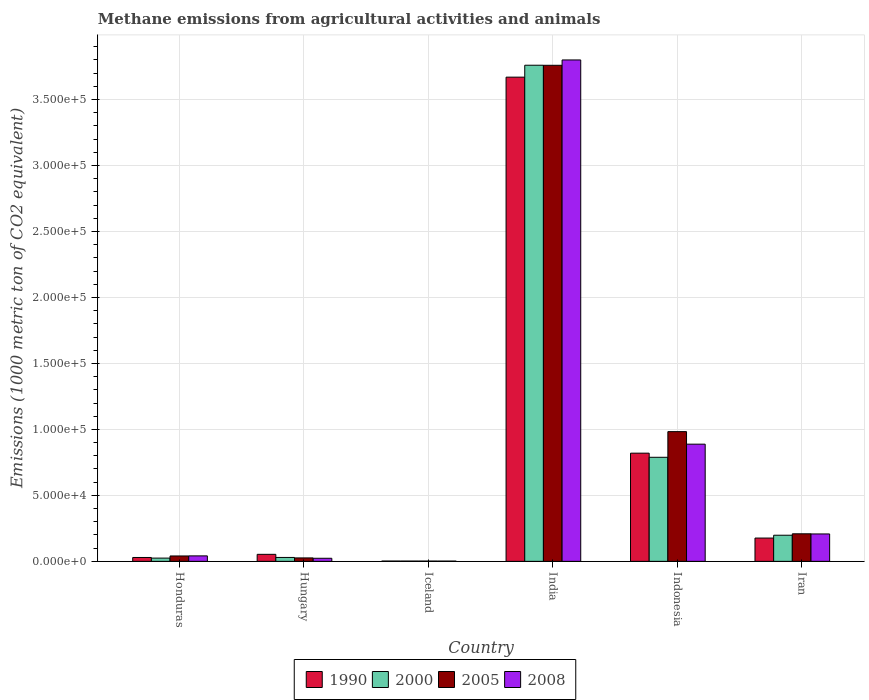How many groups of bars are there?
Make the answer very short. 6. Are the number of bars per tick equal to the number of legend labels?
Your answer should be very brief. Yes. How many bars are there on the 2nd tick from the left?
Offer a terse response. 4. How many bars are there on the 2nd tick from the right?
Keep it short and to the point. 4. What is the label of the 6th group of bars from the left?
Your answer should be compact. Iran. What is the amount of methane emitted in 1990 in Iceland?
Give a very brief answer. 245.3. Across all countries, what is the maximum amount of methane emitted in 2005?
Your answer should be compact. 3.76e+05. Across all countries, what is the minimum amount of methane emitted in 1990?
Provide a short and direct response. 245.3. In which country was the amount of methane emitted in 2008 maximum?
Offer a terse response. India. What is the total amount of methane emitted in 2008 in the graph?
Your answer should be very brief. 4.96e+05. What is the difference between the amount of methane emitted in 2008 in Hungary and that in Indonesia?
Offer a terse response. -8.65e+04. What is the difference between the amount of methane emitted in 2000 in India and the amount of methane emitted in 1990 in Iceland?
Ensure brevity in your answer.  3.76e+05. What is the average amount of methane emitted in 2008 per country?
Keep it short and to the point. 8.27e+04. What is the difference between the amount of methane emitted of/in 1990 and amount of methane emitted of/in 2008 in Hungary?
Your response must be concise. 2992.4. In how many countries, is the amount of methane emitted in 1990 greater than 40000 1000 metric ton?
Ensure brevity in your answer.  2. What is the ratio of the amount of methane emitted in 1990 in Honduras to that in Hungary?
Your answer should be very brief. 0.55. Is the difference between the amount of methane emitted in 1990 in Hungary and India greater than the difference between the amount of methane emitted in 2008 in Hungary and India?
Provide a succinct answer. Yes. What is the difference between the highest and the second highest amount of methane emitted in 1990?
Provide a succinct answer. 2.85e+05. What is the difference between the highest and the lowest amount of methane emitted in 1990?
Your response must be concise. 3.67e+05. Is it the case that in every country, the sum of the amount of methane emitted in 2008 and amount of methane emitted in 1990 is greater than the sum of amount of methane emitted in 2005 and amount of methane emitted in 2000?
Your response must be concise. No. What does the 3rd bar from the left in Indonesia represents?
Your answer should be very brief. 2005. What does the 2nd bar from the right in Indonesia represents?
Offer a terse response. 2005. Is it the case that in every country, the sum of the amount of methane emitted in 2008 and amount of methane emitted in 2005 is greater than the amount of methane emitted in 2000?
Ensure brevity in your answer.  Yes. How many bars are there?
Make the answer very short. 24. Are all the bars in the graph horizontal?
Give a very brief answer. No. How many countries are there in the graph?
Your response must be concise. 6. What is the difference between two consecutive major ticks on the Y-axis?
Ensure brevity in your answer.  5.00e+04. Are the values on the major ticks of Y-axis written in scientific E-notation?
Your answer should be very brief. Yes. Does the graph contain any zero values?
Offer a very short reply. No. Where does the legend appear in the graph?
Provide a succinct answer. Bottom center. How are the legend labels stacked?
Your response must be concise. Horizontal. What is the title of the graph?
Your response must be concise. Methane emissions from agricultural activities and animals. What is the label or title of the Y-axis?
Your response must be concise. Emissions (1000 metric ton of CO2 equivalent). What is the Emissions (1000 metric ton of CO2 equivalent) in 1990 in Honduras?
Keep it short and to the point. 2946.5. What is the Emissions (1000 metric ton of CO2 equivalent) in 2000 in Honduras?
Make the answer very short. 2470.9. What is the Emissions (1000 metric ton of CO2 equivalent) in 2005 in Honduras?
Give a very brief answer. 4084.8. What is the Emissions (1000 metric ton of CO2 equivalent) of 2008 in Honduras?
Your response must be concise. 4149.3. What is the Emissions (1000 metric ton of CO2 equivalent) of 1990 in Hungary?
Provide a short and direct response. 5327.6. What is the Emissions (1000 metric ton of CO2 equivalent) in 2000 in Hungary?
Your response must be concise. 2961.9. What is the Emissions (1000 metric ton of CO2 equivalent) in 2005 in Hungary?
Give a very brief answer. 2613. What is the Emissions (1000 metric ton of CO2 equivalent) of 2008 in Hungary?
Offer a terse response. 2335.2. What is the Emissions (1000 metric ton of CO2 equivalent) in 1990 in Iceland?
Provide a short and direct response. 245.3. What is the Emissions (1000 metric ton of CO2 equivalent) in 2000 in Iceland?
Your response must be concise. 223.7. What is the Emissions (1000 metric ton of CO2 equivalent) in 2005 in Iceland?
Keep it short and to the point. 214.9. What is the Emissions (1000 metric ton of CO2 equivalent) in 2008 in Iceland?
Your response must be concise. 209.2. What is the Emissions (1000 metric ton of CO2 equivalent) in 1990 in India?
Your response must be concise. 3.67e+05. What is the Emissions (1000 metric ton of CO2 equivalent) of 2000 in India?
Provide a succinct answer. 3.76e+05. What is the Emissions (1000 metric ton of CO2 equivalent) in 2005 in India?
Offer a terse response. 3.76e+05. What is the Emissions (1000 metric ton of CO2 equivalent) of 2008 in India?
Provide a short and direct response. 3.80e+05. What is the Emissions (1000 metric ton of CO2 equivalent) in 1990 in Indonesia?
Make the answer very short. 8.20e+04. What is the Emissions (1000 metric ton of CO2 equivalent) in 2000 in Indonesia?
Your answer should be very brief. 7.89e+04. What is the Emissions (1000 metric ton of CO2 equivalent) in 2005 in Indonesia?
Make the answer very short. 9.83e+04. What is the Emissions (1000 metric ton of CO2 equivalent) in 2008 in Indonesia?
Offer a terse response. 8.88e+04. What is the Emissions (1000 metric ton of CO2 equivalent) in 1990 in Iran?
Make the answer very short. 1.77e+04. What is the Emissions (1000 metric ton of CO2 equivalent) of 2000 in Iran?
Offer a very short reply. 1.98e+04. What is the Emissions (1000 metric ton of CO2 equivalent) in 2005 in Iran?
Your answer should be very brief. 2.09e+04. What is the Emissions (1000 metric ton of CO2 equivalent) of 2008 in Iran?
Make the answer very short. 2.08e+04. Across all countries, what is the maximum Emissions (1000 metric ton of CO2 equivalent) in 1990?
Offer a very short reply. 3.67e+05. Across all countries, what is the maximum Emissions (1000 metric ton of CO2 equivalent) of 2000?
Your answer should be very brief. 3.76e+05. Across all countries, what is the maximum Emissions (1000 metric ton of CO2 equivalent) of 2005?
Keep it short and to the point. 3.76e+05. Across all countries, what is the maximum Emissions (1000 metric ton of CO2 equivalent) of 2008?
Your answer should be compact. 3.80e+05. Across all countries, what is the minimum Emissions (1000 metric ton of CO2 equivalent) in 1990?
Ensure brevity in your answer.  245.3. Across all countries, what is the minimum Emissions (1000 metric ton of CO2 equivalent) of 2000?
Offer a very short reply. 223.7. Across all countries, what is the minimum Emissions (1000 metric ton of CO2 equivalent) of 2005?
Offer a very short reply. 214.9. Across all countries, what is the minimum Emissions (1000 metric ton of CO2 equivalent) in 2008?
Your response must be concise. 209.2. What is the total Emissions (1000 metric ton of CO2 equivalent) in 1990 in the graph?
Your response must be concise. 4.75e+05. What is the total Emissions (1000 metric ton of CO2 equivalent) of 2000 in the graph?
Ensure brevity in your answer.  4.80e+05. What is the total Emissions (1000 metric ton of CO2 equivalent) in 2005 in the graph?
Your response must be concise. 5.02e+05. What is the total Emissions (1000 metric ton of CO2 equivalent) of 2008 in the graph?
Give a very brief answer. 4.96e+05. What is the difference between the Emissions (1000 metric ton of CO2 equivalent) of 1990 in Honduras and that in Hungary?
Ensure brevity in your answer.  -2381.1. What is the difference between the Emissions (1000 metric ton of CO2 equivalent) in 2000 in Honduras and that in Hungary?
Ensure brevity in your answer.  -491. What is the difference between the Emissions (1000 metric ton of CO2 equivalent) of 2005 in Honduras and that in Hungary?
Your response must be concise. 1471.8. What is the difference between the Emissions (1000 metric ton of CO2 equivalent) of 2008 in Honduras and that in Hungary?
Your answer should be compact. 1814.1. What is the difference between the Emissions (1000 metric ton of CO2 equivalent) of 1990 in Honduras and that in Iceland?
Make the answer very short. 2701.2. What is the difference between the Emissions (1000 metric ton of CO2 equivalent) in 2000 in Honduras and that in Iceland?
Make the answer very short. 2247.2. What is the difference between the Emissions (1000 metric ton of CO2 equivalent) in 2005 in Honduras and that in Iceland?
Your answer should be very brief. 3869.9. What is the difference between the Emissions (1000 metric ton of CO2 equivalent) in 2008 in Honduras and that in Iceland?
Give a very brief answer. 3940.1. What is the difference between the Emissions (1000 metric ton of CO2 equivalent) of 1990 in Honduras and that in India?
Provide a succinct answer. -3.64e+05. What is the difference between the Emissions (1000 metric ton of CO2 equivalent) of 2000 in Honduras and that in India?
Ensure brevity in your answer.  -3.74e+05. What is the difference between the Emissions (1000 metric ton of CO2 equivalent) in 2005 in Honduras and that in India?
Your response must be concise. -3.72e+05. What is the difference between the Emissions (1000 metric ton of CO2 equivalent) of 2008 in Honduras and that in India?
Provide a succinct answer. -3.76e+05. What is the difference between the Emissions (1000 metric ton of CO2 equivalent) in 1990 in Honduras and that in Indonesia?
Keep it short and to the point. -7.91e+04. What is the difference between the Emissions (1000 metric ton of CO2 equivalent) of 2000 in Honduras and that in Indonesia?
Make the answer very short. -7.64e+04. What is the difference between the Emissions (1000 metric ton of CO2 equivalent) of 2005 in Honduras and that in Indonesia?
Keep it short and to the point. -9.42e+04. What is the difference between the Emissions (1000 metric ton of CO2 equivalent) of 2008 in Honduras and that in Indonesia?
Provide a short and direct response. -8.47e+04. What is the difference between the Emissions (1000 metric ton of CO2 equivalent) of 1990 in Honduras and that in Iran?
Your answer should be compact. -1.47e+04. What is the difference between the Emissions (1000 metric ton of CO2 equivalent) in 2000 in Honduras and that in Iran?
Provide a succinct answer. -1.73e+04. What is the difference between the Emissions (1000 metric ton of CO2 equivalent) in 2005 in Honduras and that in Iran?
Your answer should be compact. -1.68e+04. What is the difference between the Emissions (1000 metric ton of CO2 equivalent) in 2008 in Honduras and that in Iran?
Provide a short and direct response. -1.66e+04. What is the difference between the Emissions (1000 metric ton of CO2 equivalent) of 1990 in Hungary and that in Iceland?
Your answer should be compact. 5082.3. What is the difference between the Emissions (1000 metric ton of CO2 equivalent) in 2000 in Hungary and that in Iceland?
Provide a short and direct response. 2738.2. What is the difference between the Emissions (1000 metric ton of CO2 equivalent) of 2005 in Hungary and that in Iceland?
Provide a short and direct response. 2398.1. What is the difference between the Emissions (1000 metric ton of CO2 equivalent) of 2008 in Hungary and that in Iceland?
Make the answer very short. 2126. What is the difference between the Emissions (1000 metric ton of CO2 equivalent) of 1990 in Hungary and that in India?
Offer a very short reply. -3.62e+05. What is the difference between the Emissions (1000 metric ton of CO2 equivalent) in 2000 in Hungary and that in India?
Keep it short and to the point. -3.73e+05. What is the difference between the Emissions (1000 metric ton of CO2 equivalent) in 2005 in Hungary and that in India?
Your response must be concise. -3.73e+05. What is the difference between the Emissions (1000 metric ton of CO2 equivalent) of 2008 in Hungary and that in India?
Make the answer very short. -3.78e+05. What is the difference between the Emissions (1000 metric ton of CO2 equivalent) in 1990 in Hungary and that in Indonesia?
Make the answer very short. -7.67e+04. What is the difference between the Emissions (1000 metric ton of CO2 equivalent) of 2000 in Hungary and that in Indonesia?
Give a very brief answer. -7.59e+04. What is the difference between the Emissions (1000 metric ton of CO2 equivalent) in 2005 in Hungary and that in Indonesia?
Your answer should be very brief. -9.57e+04. What is the difference between the Emissions (1000 metric ton of CO2 equivalent) in 2008 in Hungary and that in Indonesia?
Provide a short and direct response. -8.65e+04. What is the difference between the Emissions (1000 metric ton of CO2 equivalent) of 1990 in Hungary and that in Iran?
Your response must be concise. -1.23e+04. What is the difference between the Emissions (1000 metric ton of CO2 equivalent) in 2000 in Hungary and that in Iran?
Your response must be concise. -1.68e+04. What is the difference between the Emissions (1000 metric ton of CO2 equivalent) of 2005 in Hungary and that in Iran?
Keep it short and to the point. -1.83e+04. What is the difference between the Emissions (1000 metric ton of CO2 equivalent) of 2008 in Hungary and that in Iran?
Provide a short and direct response. -1.84e+04. What is the difference between the Emissions (1000 metric ton of CO2 equivalent) of 1990 in Iceland and that in India?
Your response must be concise. -3.67e+05. What is the difference between the Emissions (1000 metric ton of CO2 equivalent) in 2000 in Iceland and that in India?
Your answer should be compact. -3.76e+05. What is the difference between the Emissions (1000 metric ton of CO2 equivalent) of 2005 in Iceland and that in India?
Provide a succinct answer. -3.76e+05. What is the difference between the Emissions (1000 metric ton of CO2 equivalent) of 2008 in Iceland and that in India?
Make the answer very short. -3.80e+05. What is the difference between the Emissions (1000 metric ton of CO2 equivalent) of 1990 in Iceland and that in Indonesia?
Offer a very short reply. -8.18e+04. What is the difference between the Emissions (1000 metric ton of CO2 equivalent) in 2000 in Iceland and that in Indonesia?
Keep it short and to the point. -7.86e+04. What is the difference between the Emissions (1000 metric ton of CO2 equivalent) in 2005 in Iceland and that in Indonesia?
Offer a very short reply. -9.81e+04. What is the difference between the Emissions (1000 metric ton of CO2 equivalent) in 2008 in Iceland and that in Indonesia?
Make the answer very short. -8.86e+04. What is the difference between the Emissions (1000 metric ton of CO2 equivalent) in 1990 in Iceland and that in Iran?
Your answer should be very brief. -1.74e+04. What is the difference between the Emissions (1000 metric ton of CO2 equivalent) of 2000 in Iceland and that in Iran?
Your answer should be very brief. -1.96e+04. What is the difference between the Emissions (1000 metric ton of CO2 equivalent) of 2005 in Iceland and that in Iran?
Give a very brief answer. -2.07e+04. What is the difference between the Emissions (1000 metric ton of CO2 equivalent) in 2008 in Iceland and that in Iran?
Keep it short and to the point. -2.06e+04. What is the difference between the Emissions (1000 metric ton of CO2 equivalent) in 1990 in India and that in Indonesia?
Your response must be concise. 2.85e+05. What is the difference between the Emissions (1000 metric ton of CO2 equivalent) in 2000 in India and that in Indonesia?
Your answer should be very brief. 2.97e+05. What is the difference between the Emissions (1000 metric ton of CO2 equivalent) of 2005 in India and that in Indonesia?
Give a very brief answer. 2.78e+05. What is the difference between the Emissions (1000 metric ton of CO2 equivalent) of 2008 in India and that in Indonesia?
Your response must be concise. 2.91e+05. What is the difference between the Emissions (1000 metric ton of CO2 equivalent) in 1990 in India and that in Iran?
Your answer should be compact. 3.49e+05. What is the difference between the Emissions (1000 metric ton of CO2 equivalent) in 2000 in India and that in Iran?
Your answer should be very brief. 3.56e+05. What is the difference between the Emissions (1000 metric ton of CO2 equivalent) of 2005 in India and that in Iran?
Make the answer very short. 3.55e+05. What is the difference between the Emissions (1000 metric ton of CO2 equivalent) of 2008 in India and that in Iran?
Give a very brief answer. 3.59e+05. What is the difference between the Emissions (1000 metric ton of CO2 equivalent) of 1990 in Indonesia and that in Iran?
Keep it short and to the point. 6.43e+04. What is the difference between the Emissions (1000 metric ton of CO2 equivalent) of 2000 in Indonesia and that in Iran?
Offer a terse response. 5.91e+04. What is the difference between the Emissions (1000 metric ton of CO2 equivalent) of 2005 in Indonesia and that in Iran?
Offer a very short reply. 7.74e+04. What is the difference between the Emissions (1000 metric ton of CO2 equivalent) of 2008 in Indonesia and that in Iran?
Ensure brevity in your answer.  6.80e+04. What is the difference between the Emissions (1000 metric ton of CO2 equivalent) in 1990 in Honduras and the Emissions (1000 metric ton of CO2 equivalent) in 2000 in Hungary?
Ensure brevity in your answer.  -15.4. What is the difference between the Emissions (1000 metric ton of CO2 equivalent) of 1990 in Honduras and the Emissions (1000 metric ton of CO2 equivalent) of 2005 in Hungary?
Your response must be concise. 333.5. What is the difference between the Emissions (1000 metric ton of CO2 equivalent) in 1990 in Honduras and the Emissions (1000 metric ton of CO2 equivalent) in 2008 in Hungary?
Your answer should be compact. 611.3. What is the difference between the Emissions (1000 metric ton of CO2 equivalent) in 2000 in Honduras and the Emissions (1000 metric ton of CO2 equivalent) in 2005 in Hungary?
Offer a very short reply. -142.1. What is the difference between the Emissions (1000 metric ton of CO2 equivalent) of 2000 in Honduras and the Emissions (1000 metric ton of CO2 equivalent) of 2008 in Hungary?
Provide a succinct answer. 135.7. What is the difference between the Emissions (1000 metric ton of CO2 equivalent) in 2005 in Honduras and the Emissions (1000 metric ton of CO2 equivalent) in 2008 in Hungary?
Provide a short and direct response. 1749.6. What is the difference between the Emissions (1000 metric ton of CO2 equivalent) in 1990 in Honduras and the Emissions (1000 metric ton of CO2 equivalent) in 2000 in Iceland?
Your answer should be compact. 2722.8. What is the difference between the Emissions (1000 metric ton of CO2 equivalent) in 1990 in Honduras and the Emissions (1000 metric ton of CO2 equivalent) in 2005 in Iceland?
Your answer should be very brief. 2731.6. What is the difference between the Emissions (1000 metric ton of CO2 equivalent) in 1990 in Honduras and the Emissions (1000 metric ton of CO2 equivalent) in 2008 in Iceland?
Make the answer very short. 2737.3. What is the difference between the Emissions (1000 metric ton of CO2 equivalent) of 2000 in Honduras and the Emissions (1000 metric ton of CO2 equivalent) of 2005 in Iceland?
Ensure brevity in your answer.  2256. What is the difference between the Emissions (1000 metric ton of CO2 equivalent) in 2000 in Honduras and the Emissions (1000 metric ton of CO2 equivalent) in 2008 in Iceland?
Keep it short and to the point. 2261.7. What is the difference between the Emissions (1000 metric ton of CO2 equivalent) of 2005 in Honduras and the Emissions (1000 metric ton of CO2 equivalent) of 2008 in Iceland?
Offer a very short reply. 3875.6. What is the difference between the Emissions (1000 metric ton of CO2 equivalent) in 1990 in Honduras and the Emissions (1000 metric ton of CO2 equivalent) in 2000 in India?
Offer a terse response. -3.73e+05. What is the difference between the Emissions (1000 metric ton of CO2 equivalent) in 1990 in Honduras and the Emissions (1000 metric ton of CO2 equivalent) in 2005 in India?
Provide a succinct answer. -3.73e+05. What is the difference between the Emissions (1000 metric ton of CO2 equivalent) in 1990 in Honduras and the Emissions (1000 metric ton of CO2 equivalent) in 2008 in India?
Make the answer very short. -3.77e+05. What is the difference between the Emissions (1000 metric ton of CO2 equivalent) in 2000 in Honduras and the Emissions (1000 metric ton of CO2 equivalent) in 2005 in India?
Give a very brief answer. -3.73e+05. What is the difference between the Emissions (1000 metric ton of CO2 equivalent) of 2000 in Honduras and the Emissions (1000 metric ton of CO2 equivalent) of 2008 in India?
Provide a succinct answer. -3.78e+05. What is the difference between the Emissions (1000 metric ton of CO2 equivalent) in 2005 in Honduras and the Emissions (1000 metric ton of CO2 equivalent) in 2008 in India?
Offer a very short reply. -3.76e+05. What is the difference between the Emissions (1000 metric ton of CO2 equivalent) in 1990 in Honduras and the Emissions (1000 metric ton of CO2 equivalent) in 2000 in Indonesia?
Offer a very short reply. -7.59e+04. What is the difference between the Emissions (1000 metric ton of CO2 equivalent) of 1990 in Honduras and the Emissions (1000 metric ton of CO2 equivalent) of 2005 in Indonesia?
Your answer should be very brief. -9.54e+04. What is the difference between the Emissions (1000 metric ton of CO2 equivalent) of 1990 in Honduras and the Emissions (1000 metric ton of CO2 equivalent) of 2008 in Indonesia?
Your answer should be very brief. -8.59e+04. What is the difference between the Emissions (1000 metric ton of CO2 equivalent) of 2000 in Honduras and the Emissions (1000 metric ton of CO2 equivalent) of 2005 in Indonesia?
Make the answer very short. -9.58e+04. What is the difference between the Emissions (1000 metric ton of CO2 equivalent) in 2000 in Honduras and the Emissions (1000 metric ton of CO2 equivalent) in 2008 in Indonesia?
Provide a succinct answer. -8.63e+04. What is the difference between the Emissions (1000 metric ton of CO2 equivalent) in 2005 in Honduras and the Emissions (1000 metric ton of CO2 equivalent) in 2008 in Indonesia?
Make the answer very short. -8.47e+04. What is the difference between the Emissions (1000 metric ton of CO2 equivalent) in 1990 in Honduras and the Emissions (1000 metric ton of CO2 equivalent) in 2000 in Iran?
Keep it short and to the point. -1.69e+04. What is the difference between the Emissions (1000 metric ton of CO2 equivalent) in 1990 in Honduras and the Emissions (1000 metric ton of CO2 equivalent) in 2005 in Iran?
Your response must be concise. -1.79e+04. What is the difference between the Emissions (1000 metric ton of CO2 equivalent) in 1990 in Honduras and the Emissions (1000 metric ton of CO2 equivalent) in 2008 in Iran?
Keep it short and to the point. -1.78e+04. What is the difference between the Emissions (1000 metric ton of CO2 equivalent) in 2000 in Honduras and the Emissions (1000 metric ton of CO2 equivalent) in 2005 in Iran?
Your response must be concise. -1.84e+04. What is the difference between the Emissions (1000 metric ton of CO2 equivalent) in 2000 in Honduras and the Emissions (1000 metric ton of CO2 equivalent) in 2008 in Iran?
Provide a succinct answer. -1.83e+04. What is the difference between the Emissions (1000 metric ton of CO2 equivalent) of 2005 in Honduras and the Emissions (1000 metric ton of CO2 equivalent) of 2008 in Iran?
Your answer should be compact. -1.67e+04. What is the difference between the Emissions (1000 metric ton of CO2 equivalent) in 1990 in Hungary and the Emissions (1000 metric ton of CO2 equivalent) in 2000 in Iceland?
Your answer should be very brief. 5103.9. What is the difference between the Emissions (1000 metric ton of CO2 equivalent) in 1990 in Hungary and the Emissions (1000 metric ton of CO2 equivalent) in 2005 in Iceland?
Make the answer very short. 5112.7. What is the difference between the Emissions (1000 metric ton of CO2 equivalent) in 1990 in Hungary and the Emissions (1000 metric ton of CO2 equivalent) in 2008 in Iceland?
Provide a succinct answer. 5118.4. What is the difference between the Emissions (1000 metric ton of CO2 equivalent) of 2000 in Hungary and the Emissions (1000 metric ton of CO2 equivalent) of 2005 in Iceland?
Your response must be concise. 2747. What is the difference between the Emissions (1000 metric ton of CO2 equivalent) in 2000 in Hungary and the Emissions (1000 metric ton of CO2 equivalent) in 2008 in Iceland?
Your answer should be very brief. 2752.7. What is the difference between the Emissions (1000 metric ton of CO2 equivalent) of 2005 in Hungary and the Emissions (1000 metric ton of CO2 equivalent) of 2008 in Iceland?
Give a very brief answer. 2403.8. What is the difference between the Emissions (1000 metric ton of CO2 equivalent) in 1990 in Hungary and the Emissions (1000 metric ton of CO2 equivalent) in 2000 in India?
Give a very brief answer. -3.71e+05. What is the difference between the Emissions (1000 metric ton of CO2 equivalent) in 1990 in Hungary and the Emissions (1000 metric ton of CO2 equivalent) in 2005 in India?
Your response must be concise. -3.71e+05. What is the difference between the Emissions (1000 metric ton of CO2 equivalent) in 1990 in Hungary and the Emissions (1000 metric ton of CO2 equivalent) in 2008 in India?
Offer a very short reply. -3.75e+05. What is the difference between the Emissions (1000 metric ton of CO2 equivalent) in 2000 in Hungary and the Emissions (1000 metric ton of CO2 equivalent) in 2005 in India?
Make the answer very short. -3.73e+05. What is the difference between the Emissions (1000 metric ton of CO2 equivalent) of 2000 in Hungary and the Emissions (1000 metric ton of CO2 equivalent) of 2008 in India?
Provide a succinct answer. -3.77e+05. What is the difference between the Emissions (1000 metric ton of CO2 equivalent) of 2005 in Hungary and the Emissions (1000 metric ton of CO2 equivalent) of 2008 in India?
Make the answer very short. -3.77e+05. What is the difference between the Emissions (1000 metric ton of CO2 equivalent) in 1990 in Hungary and the Emissions (1000 metric ton of CO2 equivalent) in 2000 in Indonesia?
Ensure brevity in your answer.  -7.35e+04. What is the difference between the Emissions (1000 metric ton of CO2 equivalent) in 1990 in Hungary and the Emissions (1000 metric ton of CO2 equivalent) in 2005 in Indonesia?
Offer a terse response. -9.30e+04. What is the difference between the Emissions (1000 metric ton of CO2 equivalent) in 1990 in Hungary and the Emissions (1000 metric ton of CO2 equivalent) in 2008 in Indonesia?
Keep it short and to the point. -8.35e+04. What is the difference between the Emissions (1000 metric ton of CO2 equivalent) of 2000 in Hungary and the Emissions (1000 metric ton of CO2 equivalent) of 2005 in Indonesia?
Ensure brevity in your answer.  -9.53e+04. What is the difference between the Emissions (1000 metric ton of CO2 equivalent) of 2000 in Hungary and the Emissions (1000 metric ton of CO2 equivalent) of 2008 in Indonesia?
Keep it short and to the point. -8.59e+04. What is the difference between the Emissions (1000 metric ton of CO2 equivalent) of 2005 in Hungary and the Emissions (1000 metric ton of CO2 equivalent) of 2008 in Indonesia?
Provide a short and direct response. -8.62e+04. What is the difference between the Emissions (1000 metric ton of CO2 equivalent) of 1990 in Hungary and the Emissions (1000 metric ton of CO2 equivalent) of 2000 in Iran?
Keep it short and to the point. -1.45e+04. What is the difference between the Emissions (1000 metric ton of CO2 equivalent) in 1990 in Hungary and the Emissions (1000 metric ton of CO2 equivalent) in 2005 in Iran?
Ensure brevity in your answer.  -1.56e+04. What is the difference between the Emissions (1000 metric ton of CO2 equivalent) of 1990 in Hungary and the Emissions (1000 metric ton of CO2 equivalent) of 2008 in Iran?
Keep it short and to the point. -1.54e+04. What is the difference between the Emissions (1000 metric ton of CO2 equivalent) of 2000 in Hungary and the Emissions (1000 metric ton of CO2 equivalent) of 2005 in Iran?
Provide a succinct answer. -1.79e+04. What is the difference between the Emissions (1000 metric ton of CO2 equivalent) in 2000 in Hungary and the Emissions (1000 metric ton of CO2 equivalent) in 2008 in Iran?
Provide a succinct answer. -1.78e+04. What is the difference between the Emissions (1000 metric ton of CO2 equivalent) in 2005 in Hungary and the Emissions (1000 metric ton of CO2 equivalent) in 2008 in Iran?
Provide a succinct answer. -1.82e+04. What is the difference between the Emissions (1000 metric ton of CO2 equivalent) in 1990 in Iceland and the Emissions (1000 metric ton of CO2 equivalent) in 2000 in India?
Offer a very short reply. -3.76e+05. What is the difference between the Emissions (1000 metric ton of CO2 equivalent) of 1990 in Iceland and the Emissions (1000 metric ton of CO2 equivalent) of 2005 in India?
Your answer should be compact. -3.76e+05. What is the difference between the Emissions (1000 metric ton of CO2 equivalent) in 1990 in Iceland and the Emissions (1000 metric ton of CO2 equivalent) in 2008 in India?
Your answer should be very brief. -3.80e+05. What is the difference between the Emissions (1000 metric ton of CO2 equivalent) in 2000 in Iceland and the Emissions (1000 metric ton of CO2 equivalent) in 2005 in India?
Give a very brief answer. -3.76e+05. What is the difference between the Emissions (1000 metric ton of CO2 equivalent) of 2000 in Iceland and the Emissions (1000 metric ton of CO2 equivalent) of 2008 in India?
Your answer should be compact. -3.80e+05. What is the difference between the Emissions (1000 metric ton of CO2 equivalent) of 2005 in Iceland and the Emissions (1000 metric ton of CO2 equivalent) of 2008 in India?
Offer a very short reply. -3.80e+05. What is the difference between the Emissions (1000 metric ton of CO2 equivalent) of 1990 in Iceland and the Emissions (1000 metric ton of CO2 equivalent) of 2000 in Indonesia?
Offer a very short reply. -7.86e+04. What is the difference between the Emissions (1000 metric ton of CO2 equivalent) of 1990 in Iceland and the Emissions (1000 metric ton of CO2 equivalent) of 2005 in Indonesia?
Offer a very short reply. -9.81e+04. What is the difference between the Emissions (1000 metric ton of CO2 equivalent) in 1990 in Iceland and the Emissions (1000 metric ton of CO2 equivalent) in 2008 in Indonesia?
Keep it short and to the point. -8.86e+04. What is the difference between the Emissions (1000 metric ton of CO2 equivalent) of 2000 in Iceland and the Emissions (1000 metric ton of CO2 equivalent) of 2005 in Indonesia?
Keep it short and to the point. -9.81e+04. What is the difference between the Emissions (1000 metric ton of CO2 equivalent) of 2000 in Iceland and the Emissions (1000 metric ton of CO2 equivalent) of 2008 in Indonesia?
Your response must be concise. -8.86e+04. What is the difference between the Emissions (1000 metric ton of CO2 equivalent) of 2005 in Iceland and the Emissions (1000 metric ton of CO2 equivalent) of 2008 in Indonesia?
Your answer should be very brief. -8.86e+04. What is the difference between the Emissions (1000 metric ton of CO2 equivalent) in 1990 in Iceland and the Emissions (1000 metric ton of CO2 equivalent) in 2000 in Iran?
Your answer should be very brief. -1.96e+04. What is the difference between the Emissions (1000 metric ton of CO2 equivalent) of 1990 in Iceland and the Emissions (1000 metric ton of CO2 equivalent) of 2005 in Iran?
Ensure brevity in your answer.  -2.06e+04. What is the difference between the Emissions (1000 metric ton of CO2 equivalent) in 1990 in Iceland and the Emissions (1000 metric ton of CO2 equivalent) in 2008 in Iran?
Offer a terse response. -2.05e+04. What is the difference between the Emissions (1000 metric ton of CO2 equivalent) in 2000 in Iceland and the Emissions (1000 metric ton of CO2 equivalent) in 2005 in Iran?
Make the answer very short. -2.07e+04. What is the difference between the Emissions (1000 metric ton of CO2 equivalent) in 2000 in Iceland and the Emissions (1000 metric ton of CO2 equivalent) in 2008 in Iran?
Ensure brevity in your answer.  -2.06e+04. What is the difference between the Emissions (1000 metric ton of CO2 equivalent) of 2005 in Iceland and the Emissions (1000 metric ton of CO2 equivalent) of 2008 in Iran?
Make the answer very short. -2.06e+04. What is the difference between the Emissions (1000 metric ton of CO2 equivalent) of 1990 in India and the Emissions (1000 metric ton of CO2 equivalent) of 2000 in Indonesia?
Your response must be concise. 2.88e+05. What is the difference between the Emissions (1000 metric ton of CO2 equivalent) in 1990 in India and the Emissions (1000 metric ton of CO2 equivalent) in 2005 in Indonesia?
Make the answer very short. 2.69e+05. What is the difference between the Emissions (1000 metric ton of CO2 equivalent) in 1990 in India and the Emissions (1000 metric ton of CO2 equivalent) in 2008 in Indonesia?
Offer a terse response. 2.78e+05. What is the difference between the Emissions (1000 metric ton of CO2 equivalent) in 2000 in India and the Emissions (1000 metric ton of CO2 equivalent) in 2005 in Indonesia?
Provide a short and direct response. 2.78e+05. What is the difference between the Emissions (1000 metric ton of CO2 equivalent) in 2000 in India and the Emissions (1000 metric ton of CO2 equivalent) in 2008 in Indonesia?
Give a very brief answer. 2.87e+05. What is the difference between the Emissions (1000 metric ton of CO2 equivalent) of 2005 in India and the Emissions (1000 metric ton of CO2 equivalent) of 2008 in Indonesia?
Your answer should be compact. 2.87e+05. What is the difference between the Emissions (1000 metric ton of CO2 equivalent) in 1990 in India and the Emissions (1000 metric ton of CO2 equivalent) in 2000 in Iran?
Your answer should be very brief. 3.47e+05. What is the difference between the Emissions (1000 metric ton of CO2 equivalent) of 1990 in India and the Emissions (1000 metric ton of CO2 equivalent) of 2005 in Iran?
Provide a short and direct response. 3.46e+05. What is the difference between the Emissions (1000 metric ton of CO2 equivalent) of 1990 in India and the Emissions (1000 metric ton of CO2 equivalent) of 2008 in Iran?
Keep it short and to the point. 3.46e+05. What is the difference between the Emissions (1000 metric ton of CO2 equivalent) of 2000 in India and the Emissions (1000 metric ton of CO2 equivalent) of 2005 in Iran?
Your answer should be very brief. 3.55e+05. What is the difference between the Emissions (1000 metric ton of CO2 equivalent) of 2000 in India and the Emissions (1000 metric ton of CO2 equivalent) of 2008 in Iran?
Make the answer very short. 3.55e+05. What is the difference between the Emissions (1000 metric ton of CO2 equivalent) in 2005 in India and the Emissions (1000 metric ton of CO2 equivalent) in 2008 in Iran?
Offer a very short reply. 3.55e+05. What is the difference between the Emissions (1000 metric ton of CO2 equivalent) in 1990 in Indonesia and the Emissions (1000 metric ton of CO2 equivalent) in 2000 in Iran?
Your answer should be very brief. 6.22e+04. What is the difference between the Emissions (1000 metric ton of CO2 equivalent) of 1990 in Indonesia and the Emissions (1000 metric ton of CO2 equivalent) of 2005 in Iran?
Keep it short and to the point. 6.11e+04. What is the difference between the Emissions (1000 metric ton of CO2 equivalent) in 1990 in Indonesia and the Emissions (1000 metric ton of CO2 equivalent) in 2008 in Iran?
Your answer should be very brief. 6.12e+04. What is the difference between the Emissions (1000 metric ton of CO2 equivalent) in 2000 in Indonesia and the Emissions (1000 metric ton of CO2 equivalent) in 2005 in Iran?
Offer a very short reply. 5.80e+04. What is the difference between the Emissions (1000 metric ton of CO2 equivalent) in 2000 in Indonesia and the Emissions (1000 metric ton of CO2 equivalent) in 2008 in Iran?
Give a very brief answer. 5.81e+04. What is the difference between the Emissions (1000 metric ton of CO2 equivalent) of 2005 in Indonesia and the Emissions (1000 metric ton of CO2 equivalent) of 2008 in Iran?
Provide a succinct answer. 7.75e+04. What is the average Emissions (1000 metric ton of CO2 equivalent) in 1990 per country?
Ensure brevity in your answer.  7.92e+04. What is the average Emissions (1000 metric ton of CO2 equivalent) in 2000 per country?
Offer a very short reply. 8.00e+04. What is the average Emissions (1000 metric ton of CO2 equivalent) in 2005 per country?
Provide a succinct answer. 8.37e+04. What is the average Emissions (1000 metric ton of CO2 equivalent) in 2008 per country?
Give a very brief answer. 8.27e+04. What is the difference between the Emissions (1000 metric ton of CO2 equivalent) in 1990 and Emissions (1000 metric ton of CO2 equivalent) in 2000 in Honduras?
Offer a terse response. 475.6. What is the difference between the Emissions (1000 metric ton of CO2 equivalent) of 1990 and Emissions (1000 metric ton of CO2 equivalent) of 2005 in Honduras?
Your response must be concise. -1138.3. What is the difference between the Emissions (1000 metric ton of CO2 equivalent) of 1990 and Emissions (1000 metric ton of CO2 equivalent) of 2008 in Honduras?
Give a very brief answer. -1202.8. What is the difference between the Emissions (1000 metric ton of CO2 equivalent) in 2000 and Emissions (1000 metric ton of CO2 equivalent) in 2005 in Honduras?
Ensure brevity in your answer.  -1613.9. What is the difference between the Emissions (1000 metric ton of CO2 equivalent) in 2000 and Emissions (1000 metric ton of CO2 equivalent) in 2008 in Honduras?
Your response must be concise. -1678.4. What is the difference between the Emissions (1000 metric ton of CO2 equivalent) of 2005 and Emissions (1000 metric ton of CO2 equivalent) of 2008 in Honduras?
Your answer should be very brief. -64.5. What is the difference between the Emissions (1000 metric ton of CO2 equivalent) of 1990 and Emissions (1000 metric ton of CO2 equivalent) of 2000 in Hungary?
Ensure brevity in your answer.  2365.7. What is the difference between the Emissions (1000 metric ton of CO2 equivalent) of 1990 and Emissions (1000 metric ton of CO2 equivalent) of 2005 in Hungary?
Offer a terse response. 2714.6. What is the difference between the Emissions (1000 metric ton of CO2 equivalent) of 1990 and Emissions (1000 metric ton of CO2 equivalent) of 2008 in Hungary?
Keep it short and to the point. 2992.4. What is the difference between the Emissions (1000 metric ton of CO2 equivalent) in 2000 and Emissions (1000 metric ton of CO2 equivalent) in 2005 in Hungary?
Provide a short and direct response. 348.9. What is the difference between the Emissions (1000 metric ton of CO2 equivalent) in 2000 and Emissions (1000 metric ton of CO2 equivalent) in 2008 in Hungary?
Ensure brevity in your answer.  626.7. What is the difference between the Emissions (1000 metric ton of CO2 equivalent) in 2005 and Emissions (1000 metric ton of CO2 equivalent) in 2008 in Hungary?
Keep it short and to the point. 277.8. What is the difference between the Emissions (1000 metric ton of CO2 equivalent) in 1990 and Emissions (1000 metric ton of CO2 equivalent) in 2000 in Iceland?
Your answer should be compact. 21.6. What is the difference between the Emissions (1000 metric ton of CO2 equivalent) in 1990 and Emissions (1000 metric ton of CO2 equivalent) in 2005 in Iceland?
Ensure brevity in your answer.  30.4. What is the difference between the Emissions (1000 metric ton of CO2 equivalent) of 1990 and Emissions (1000 metric ton of CO2 equivalent) of 2008 in Iceland?
Give a very brief answer. 36.1. What is the difference between the Emissions (1000 metric ton of CO2 equivalent) of 2000 and Emissions (1000 metric ton of CO2 equivalent) of 2008 in Iceland?
Keep it short and to the point. 14.5. What is the difference between the Emissions (1000 metric ton of CO2 equivalent) of 1990 and Emissions (1000 metric ton of CO2 equivalent) of 2000 in India?
Make the answer very short. -9029.4. What is the difference between the Emissions (1000 metric ton of CO2 equivalent) of 1990 and Emissions (1000 metric ton of CO2 equivalent) of 2005 in India?
Offer a very short reply. -8983.7. What is the difference between the Emissions (1000 metric ton of CO2 equivalent) in 1990 and Emissions (1000 metric ton of CO2 equivalent) in 2008 in India?
Your response must be concise. -1.30e+04. What is the difference between the Emissions (1000 metric ton of CO2 equivalent) of 2000 and Emissions (1000 metric ton of CO2 equivalent) of 2005 in India?
Provide a short and direct response. 45.7. What is the difference between the Emissions (1000 metric ton of CO2 equivalent) in 2000 and Emissions (1000 metric ton of CO2 equivalent) in 2008 in India?
Give a very brief answer. -4005.8. What is the difference between the Emissions (1000 metric ton of CO2 equivalent) of 2005 and Emissions (1000 metric ton of CO2 equivalent) of 2008 in India?
Keep it short and to the point. -4051.5. What is the difference between the Emissions (1000 metric ton of CO2 equivalent) of 1990 and Emissions (1000 metric ton of CO2 equivalent) of 2000 in Indonesia?
Offer a terse response. 3136.2. What is the difference between the Emissions (1000 metric ton of CO2 equivalent) of 1990 and Emissions (1000 metric ton of CO2 equivalent) of 2005 in Indonesia?
Your response must be concise. -1.63e+04. What is the difference between the Emissions (1000 metric ton of CO2 equivalent) in 1990 and Emissions (1000 metric ton of CO2 equivalent) in 2008 in Indonesia?
Your response must be concise. -6814.3. What is the difference between the Emissions (1000 metric ton of CO2 equivalent) in 2000 and Emissions (1000 metric ton of CO2 equivalent) in 2005 in Indonesia?
Ensure brevity in your answer.  -1.94e+04. What is the difference between the Emissions (1000 metric ton of CO2 equivalent) in 2000 and Emissions (1000 metric ton of CO2 equivalent) in 2008 in Indonesia?
Give a very brief answer. -9950.5. What is the difference between the Emissions (1000 metric ton of CO2 equivalent) in 2005 and Emissions (1000 metric ton of CO2 equivalent) in 2008 in Indonesia?
Offer a very short reply. 9496.1. What is the difference between the Emissions (1000 metric ton of CO2 equivalent) in 1990 and Emissions (1000 metric ton of CO2 equivalent) in 2000 in Iran?
Keep it short and to the point. -2149.4. What is the difference between the Emissions (1000 metric ton of CO2 equivalent) of 1990 and Emissions (1000 metric ton of CO2 equivalent) of 2005 in Iran?
Provide a succinct answer. -3226.3. What is the difference between the Emissions (1000 metric ton of CO2 equivalent) in 1990 and Emissions (1000 metric ton of CO2 equivalent) in 2008 in Iran?
Make the answer very short. -3119.6. What is the difference between the Emissions (1000 metric ton of CO2 equivalent) of 2000 and Emissions (1000 metric ton of CO2 equivalent) of 2005 in Iran?
Your answer should be compact. -1076.9. What is the difference between the Emissions (1000 metric ton of CO2 equivalent) in 2000 and Emissions (1000 metric ton of CO2 equivalent) in 2008 in Iran?
Your answer should be compact. -970.2. What is the difference between the Emissions (1000 metric ton of CO2 equivalent) in 2005 and Emissions (1000 metric ton of CO2 equivalent) in 2008 in Iran?
Your answer should be compact. 106.7. What is the ratio of the Emissions (1000 metric ton of CO2 equivalent) in 1990 in Honduras to that in Hungary?
Provide a short and direct response. 0.55. What is the ratio of the Emissions (1000 metric ton of CO2 equivalent) in 2000 in Honduras to that in Hungary?
Your answer should be very brief. 0.83. What is the ratio of the Emissions (1000 metric ton of CO2 equivalent) in 2005 in Honduras to that in Hungary?
Your answer should be very brief. 1.56. What is the ratio of the Emissions (1000 metric ton of CO2 equivalent) of 2008 in Honduras to that in Hungary?
Your answer should be very brief. 1.78. What is the ratio of the Emissions (1000 metric ton of CO2 equivalent) in 1990 in Honduras to that in Iceland?
Ensure brevity in your answer.  12.01. What is the ratio of the Emissions (1000 metric ton of CO2 equivalent) in 2000 in Honduras to that in Iceland?
Offer a very short reply. 11.05. What is the ratio of the Emissions (1000 metric ton of CO2 equivalent) in 2005 in Honduras to that in Iceland?
Offer a terse response. 19.01. What is the ratio of the Emissions (1000 metric ton of CO2 equivalent) of 2008 in Honduras to that in Iceland?
Offer a terse response. 19.83. What is the ratio of the Emissions (1000 metric ton of CO2 equivalent) in 1990 in Honduras to that in India?
Provide a succinct answer. 0.01. What is the ratio of the Emissions (1000 metric ton of CO2 equivalent) in 2000 in Honduras to that in India?
Make the answer very short. 0.01. What is the ratio of the Emissions (1000 metric ton of CO2 equivalent) in 2005 in Honduras to that in India?
Offer a very short reply. 0.01. What is the ratio of the Emissions (1000 metric ton of CO2 equivalent) in 2008 in Honduras to that in India?
Offer a very short reply. 0.01. What is the ratio of the Emissions (1000 metric ton of CO2 equivalent) in 1990 in Honduras to that in Indonesia?
Give a very brief answer. 0.04. What is the ratio of the Emissions (1000 metric ton of CO2 equivalent) in 2000 in Honduras to that in Indonesia?
Provide a succinct answer. 0.03. What is the ratio of the Emissions (1000 metric ton of CO2 equivalent) in 2005 in Honduras to that in Indonesia?
Provide a short and direct response. 0.04. What is the ratio of the Emissions (1000 metric ton of CO2 equivalent) in 2008 in Honduras to that in Indonesia?
Ensure brevity in your answer.  0.05. What is the ratio of the Emissions (1000 metric ton of CO2 equivalent) in 1990 in Honduras to that in Iran?
Offer a very short reply. 0.17. What is the ratio of the Emissions (1000 metric ton of CO2 equivalent) in 2000 in Honduras to that in Iran?
Your answer should be very brief. 0.12. What is the ratio of the Emissions (1000 metric ton of CO2 equivalent) in 2005 in Honduras to that in Iran?
Give a very brief answer. 0.2. What is the ratio of the Emissions (1000 metric ton of CO2 equivalent) in 2008 in Honduras to that in Iran?
Your response must be concise. 0.2. What is the ratio of the Emissions (1000 metric ton of CO2 equivalent) of 1990 in Hungary to that in Iceland?
Ensure brevity in your answer.  21.72. What is the ratio of the Emissions (1000 metric ton of CO2 equivalent) of 2000 in Hungary to that in Iceland?
Your answer should be compact. 13.24. What is the ratio of the Emissions (1000 metric ton of CO2 equivalent) of 2005 in Hungary to that in Iceland?
Provide a short and direct response. 12.16. What is the ratio of the Emissions (1000 metric ton of CO2 equivalent) of 2008 in Hungary to that in Iceland?
Your answer should be compact. 11.16. What is the ratio of the Emissions (1000 metric ton of CO2 equivalent) in 1990 in Hungary to that in India?
Keep it short and to the point. 0.01. What is the ratio of the Emissions (1000 metric ton of CO2 equivalent) in 2000 in Hungary to that in India?
Make the answer very short. 0.01. What is the ratio of the Emissions (1000 metric ton of CO2 equivalent) in 2005 in Hungary to that in India?
Your answer should be very brief. 0.01. What is the ratio of the Emissions (1000 metric ton of CO2 equivalent) in 2008 in Hungary to that in India?
Give a very brief answer. 0.01. What is the ratio of the Emissions (1000 metric ton of CO2 equivalent) in 1990 in Hungary to that in Indonesia?
Your response must be concise. 0.07. What is the ratio of the Emissions (1000 metric ton of CO2 equivalent) of 2000 in Hungary to that in Indonesia?
Make the answer very short. 0.04. What is the ratio of the Emissions (1000 metric ton of CO2 equivalent) in 2005 in Hungary to that in Indonesia?
Make the answer very short. 0.03. What is the ratio of the Emissions (1000 metric ton of CO2 equivalent) of 2008 in Hungary to that in Indonesia?
Give a very brief answer. 0.03. What is the ratio of the Emissions (1000 metric ton of CO2 equivalent) in 1990 in Hungary to that in Iran?
Provide a short and direct response. 0.3. What is the ratio of the Emissions (1000 metric ton of CO2 equivalent) of 2000 in Hungary to that in Iran?
Provide a succinct answer. 0.15. What is the ratio of the Emissions (1000 metric ton of CO2 equivalent) of 2005 in Hungary to that in Iran?
Offer a very short reply. 0.13. What is the ratio of the Emissions (1000 metric ton of CO2 equivalent) of 2008 in Hungary to that in Iran?
Offer a very short reply. 0.11. What is the ratio of the Emissions (1000 metric ton of CO2 equivalent) in 1990 in Iceland to that in India?
Offer a terse response. 0. What is the ratio of the Emissions (1000 metric ton of CO2 equivalent) in 2000 in Iceland to that in India?
Your response must be concise. 0. What is the ratio of the Emissions (1000 metric ton of CO2 equivalent) of 2005 in Iceland to that in India?
Your answer should be very brief. 0. What is the ratio of the Emissions (1000 metric ton of CO2 equivalent) in 2008 in Iceland to that in India?
Give a very brief answer. 0. What is the ratio of the Emissions (1000 metric ton of CO2 equivalent) of 1990 in Iceland to that in Indonesia?
Ensure brevity in your answer.  0. What is the ratio of the Emissions (1000 metric ton of CO2 equivalent) in 2000 in Iceland to that in Indonesia?
Keep it short and to the point. 0. What is the ratio of the Emissions (1000 metric ton of CO2 equivalent) of 2005 in Iceland to that in Indonesia?
Provide a succinct answer. 0. What is the ratio of the Emissions (1000 metric ton of CO2 equivalent) in 2008 in Iceland to that in Indonesia?
Keep it short and to the point. 0. What is the ratio of the Emissions (1000 metric ton of CO2 equivalent) of 1990 in Iceland to that in Iran?
Your response must be concise. 0.01. What is the ratio of the Emissions (1000 metric ton of CO2 equivalent) in 2000 in Iceland to that in Iran?
Your answer should be very brief. 0.01. What is the ratio of the Emissions (1000 metric ton of CO2 equivalent) of 2005 in Iceland to that in Iran?
Your answer should be compact. 0.01. What is the ratio of the Emissions (1000 metric ton of CO2 equivalent) of 2008 in Iceland to that in Iran?
Your answer should be very brief. 0.01. What is the ratio of the Emissions (1000 metric ton of CO2 equivalent) in 1990 in India to that in Indonesia?
Offer a terse response. 4.48. What is the ratio of the Emissions (1000 metric ton of CO2 equivalent) of 2000 in India to that in Indonesia?
Offer a terse response. 4.77. What is the ratio of the Emissions (1000 metric ton of CO2 equivalent) in 2005 in India to that in Indonesia?
Make the answer very short. 3.82. What is the ratio of the Emissions (1000 metric ton of CO2 equivalent) of 2008 in India to that in Indonesia?
Make the answer very short. 4.28. What is the ratio of the Emissions (1000 metric ton of CO2 equivalent) in 1990 in India to that in Iran?
Your answer should be very brief. 20.78. What is the ratio of the Emissions (1000 metric ton of CO2 equivalent) in 2000 in India to that in Iran?
Your answer should be compact. 18.98. What is the ratio of the Emissions (1000 metric ton of CO2 equivalent) of 2005 in India to that in Iran?
Make the answer very short. 18. What is the ratio of the Emissions (1000 metric ton of CO2 equivalent) in 2008 in India to that in Iran?
Your response must be concise. 18.29. What is the ratio of the Emissions (1000 metric ton of CO2 equivalent) of 1990 in Indonesia to that in Iran?
Offer a terse response. 4.64. What is the ratio of the Emissions (1000 metric ton of CO2 equivalent) of 2000 in Indonesia to that in Iran?
Your answer should be compact. 3.98. What is the ratio of the Emissions (1000 metric ton of CO2 equivalent) in 2005 in Indonesia to that in Iran?
Offer a terse response. 4.71. What is the ratio of the Emissions (1000 metric ton of CO2 equivalent) of 2008 in Indonesia to that in Iran?
Your answer should be compact. 4.27. What is the difference between the highest and the second highest Emissions (1000 metric ton of CO2 equivalent) of 1990?
Give a very brief answer. 2.85e+05. What is the difference between the highest and the second highest Emissions (1000 metric ton of CO2 equivalent) of 2000?
Give a very brief answer. 2.97e+05. What is the difference between the highest and the second highest Emissions (1000 metric ton of CO2 equivalent) in 2005?
Make the answer very short. 2.78e+05. What is the difference between the highest and the second highest Emissions (1000 metric ton of CO2 equivalent) of 2008?
Your answer should be compact. 2.91e+05. What is the difference between the highest and the lowest Emissions (1000 metric ton of CO2 equivalent) of 1990?
Your answer should be very brief. 3.67e+05. What is the difference between the highest and the lowest Emissions (1000 metric ton of CO2 equivalent) of 2000?
Make the answer very short. 3.76e+05. What is the difference between the highest and the lowest Emissions (1000 metric ton of CO2 equivalent) of 2005?
Ensure brevity in your answer.  3.76e+05. What is the difference between the highest and the lowest Emissions (1000 metric ton of CO2 equivalent) in 2008?
Offer a terse response. 3.80e+05. 